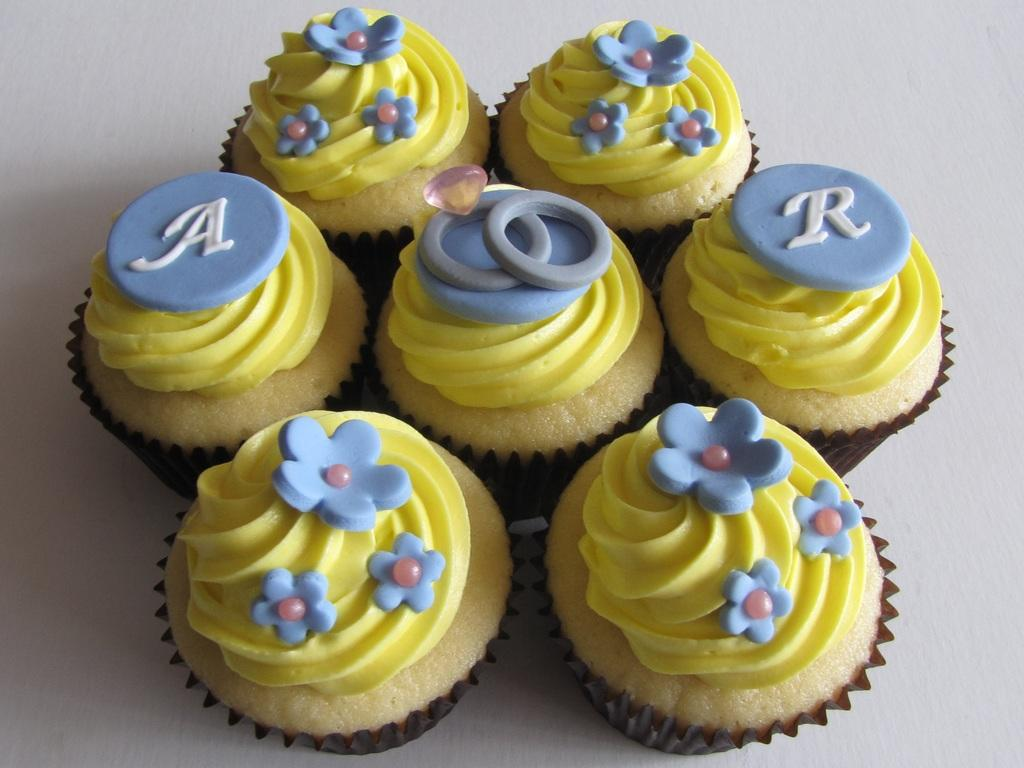What type of food can be seen in the image? There are muffins in the image. Can you describe the appearance of the muffins? The muffins appear to be baked goods, with a round shape and a possible topping or filling. How many muffins are visible in the image? The number of muffins cannot be determined from the provided facts, but there are at least one or more muffins present. What type of art is displayed on the lock in the image? There is no lock or art present in the image; it only features muffins. 